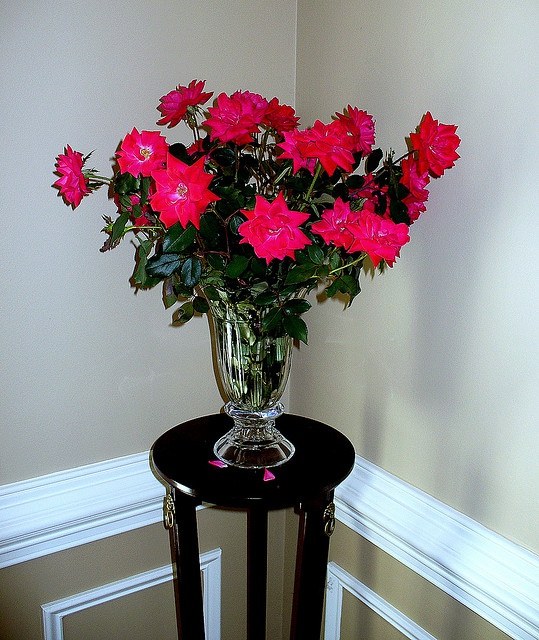Describe the objects in this image and their specific colors. I can see a vase in darkgray, black, gray, and darkgreen tones in this image. 